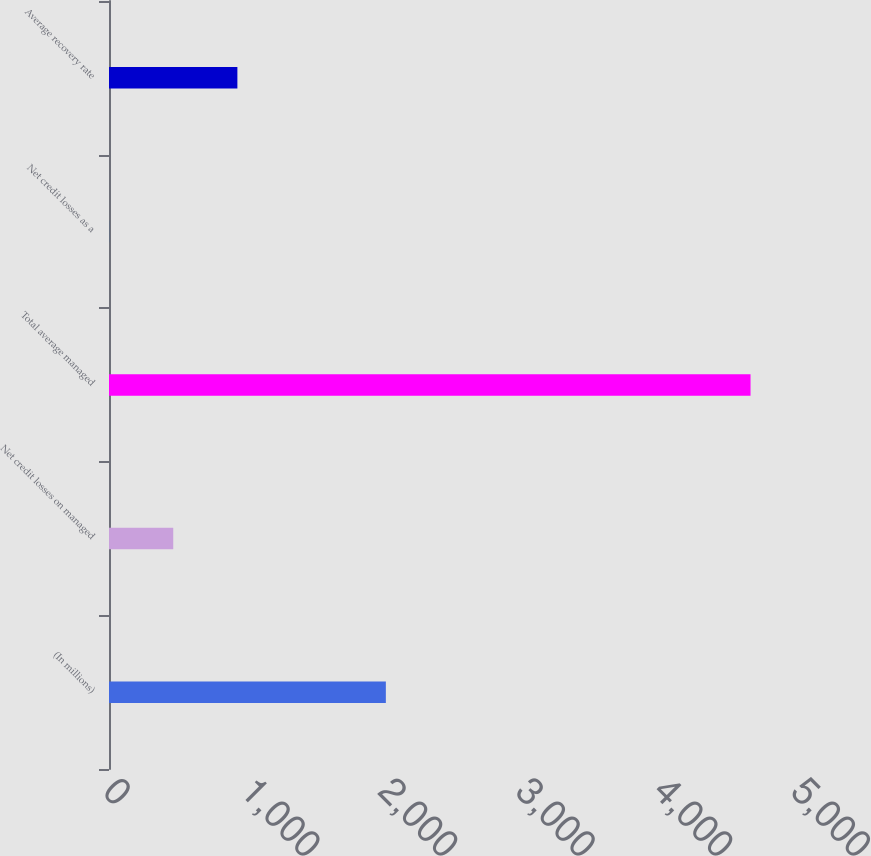Convert chart. <chart><loc_0><loc_0><loc_500><loc_500><bar_chart><fcel>(In millions)<fcel>Net credit losses on managed<fcel>Total average managed<fcel>Net credit losses as a<fcel>Average recovery rate<nl><fcel>2012<fcel>466.86<fcel>4662.4<fcel>0.69<fcel>933.03<nl></chart> 